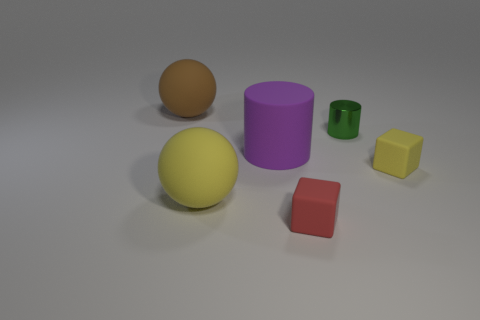Add 3 shiny spheres. How many objects exist? 9 Subtract 2 cubes. How many cubes are left? 0 Subtract all yellow cubes. How many cubes are left? 1 Subtract all spheres. How many objects are left? 4 Subtract all purple cylinders. How many brown spheres are left? 1 Subtract all small yellow blocks. Subtract all red things. How many objects are left? 4 Add 1 big brown spheres. How many big brown spheres are left? 2 Add 1 rubber objects. How many rubber objects exist? 6 Subtract 0 red balls. How many objects are left? 6 Subtract all red cubes. Subtract all cyan spheres. How many cubes are left? 1 